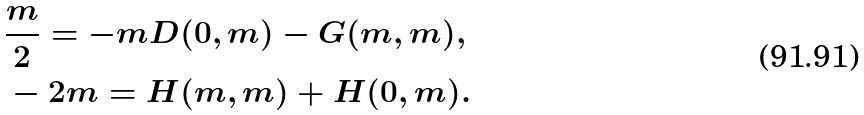<formula> <loc_0><loc_0><loc_500><loc_500>& \frac { m } { 2 } = - m D ( 0 , m ) - G ( m , m ) , \\ & - 2 m = H ( m , m ) + H ( 0 , m ) .</formula> 